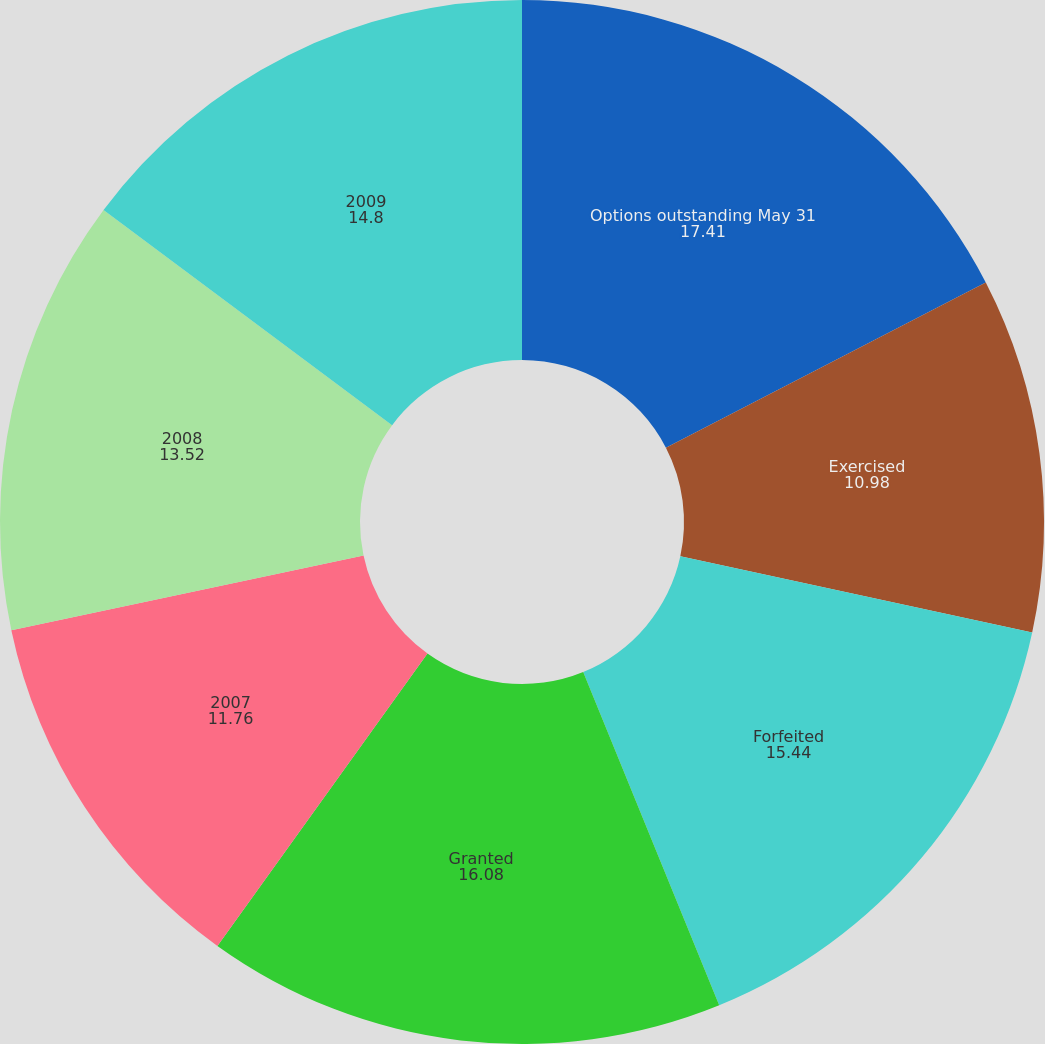Convert chart to OTSL. <chart><loc_0><loc_0><loc_500><loc_500><pie_chart><fcel>Options outstanding May 31<fcel>Exercised<fcel>Forfeited<fcel>Granted<fcel>2007<fcel>2008<fcel>2009<nl><fcel>17.41%<fcel>10.98%<fcel>15.44%<fcel>16.08%<fcel>11.76%<fcel>13.52%<fcel>14.8%<nl></chart> 